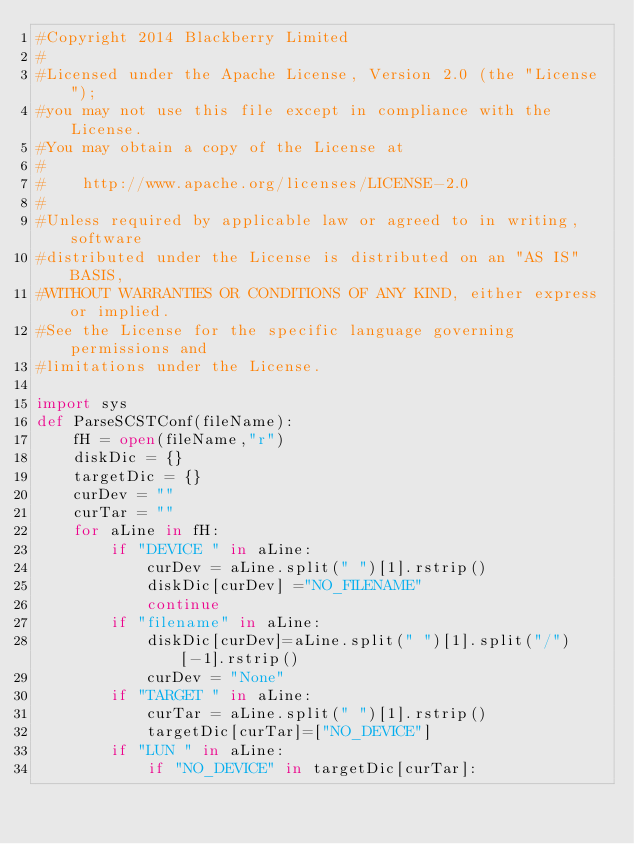Convert code to text. <code><loc_0><loc_0><loc_500><loc_500><_Python_>#Copyright 2014 Blackberry Limited
#
#Licensed under the Apache License, Version 2.0 (the "License");
#you may not use this file except in compliance with the License.
#You may obtain a copy of the License at
#
#    http://www.apache.org/licenses/LICENSE-2.0
#
#Unless required by applicable law or agreed to in writing, software
#distributed under the License is distributed on an "AS IS" BASIS,
#WITHOUT WARRANTIES OR CONDITIONS OF ANY KIND, either express or implied.
#See the License for the specific language governing permissions and
#limitations under the License.

import sys
def ParseSCSTConf(fileName):
    fH = open(fileName,"r")
    diskDic = {}
    targetDic = {}
    curDev = ""
    curTar = ""
    for aLine in fH:
        if "DEVICE " in aLine:
            curDev = aLine.split(" ")[1].rstrip()
            diskDic[curDev] ="NO_FILENAME"
            continue
        if "filename" in aLine:
            diskDic[curDev]=aLine.split(" ")[1].split("/")[-1].rstrip()
            curDev = "None"
        if "TARGET " in aLine:
            curTar = aLine.split(" ")[1].rstrip()
            targetDic[curTar]=["NO_DEVICE"]
        if "LUN " in aLine:
            if "NO_DEVICE" in targetDic[curTar]:</code> 